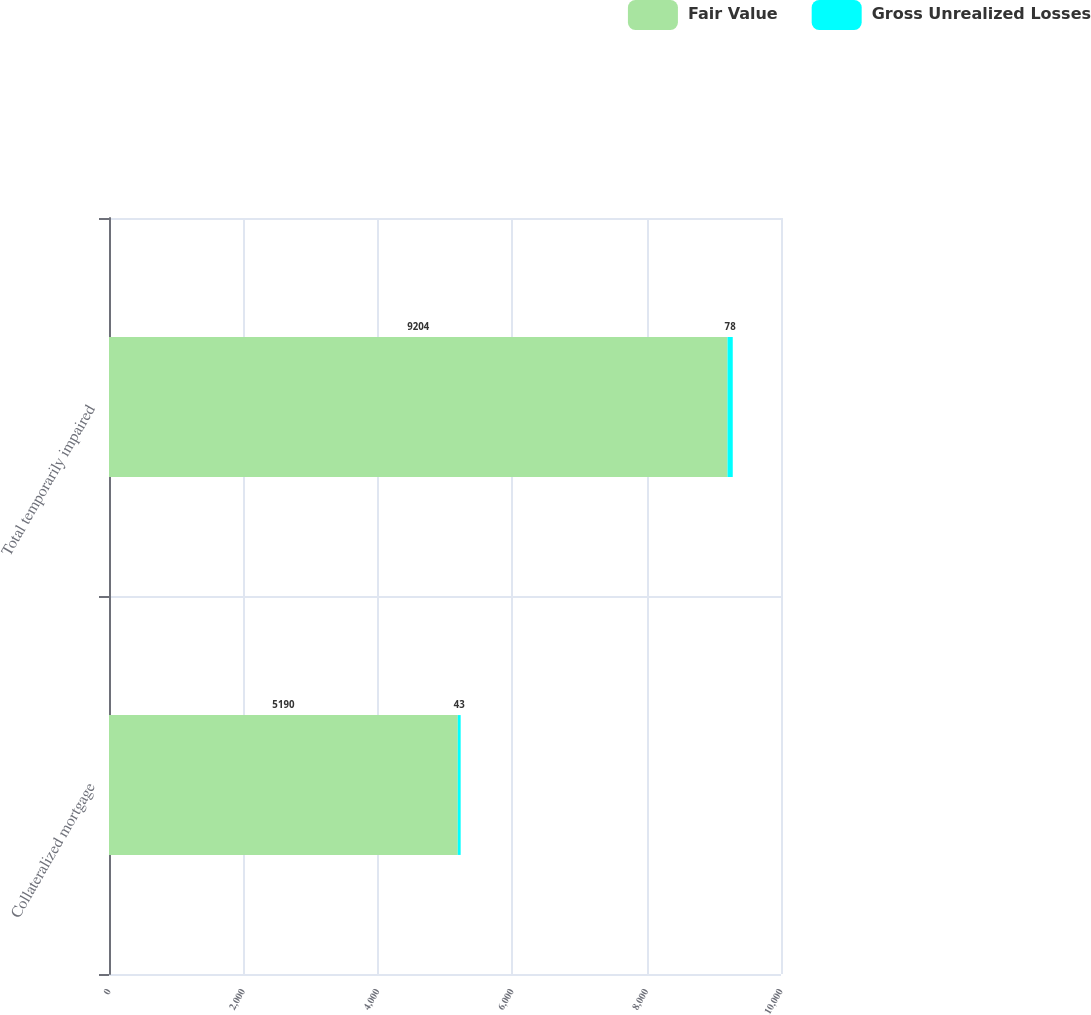Convert chart. <chart><loc_0><loc_0><loc_500><loc_500><stacked_bar_chart><ecel><fcel>Collateralized mortgage<fcel>Total temporarily impaired<nl><fcel>Fair Value<fcel>5190<fcel>9204<nl><fcel>Gross Unrealized Losses<fcel>43<fcel>78<nl></chart> 